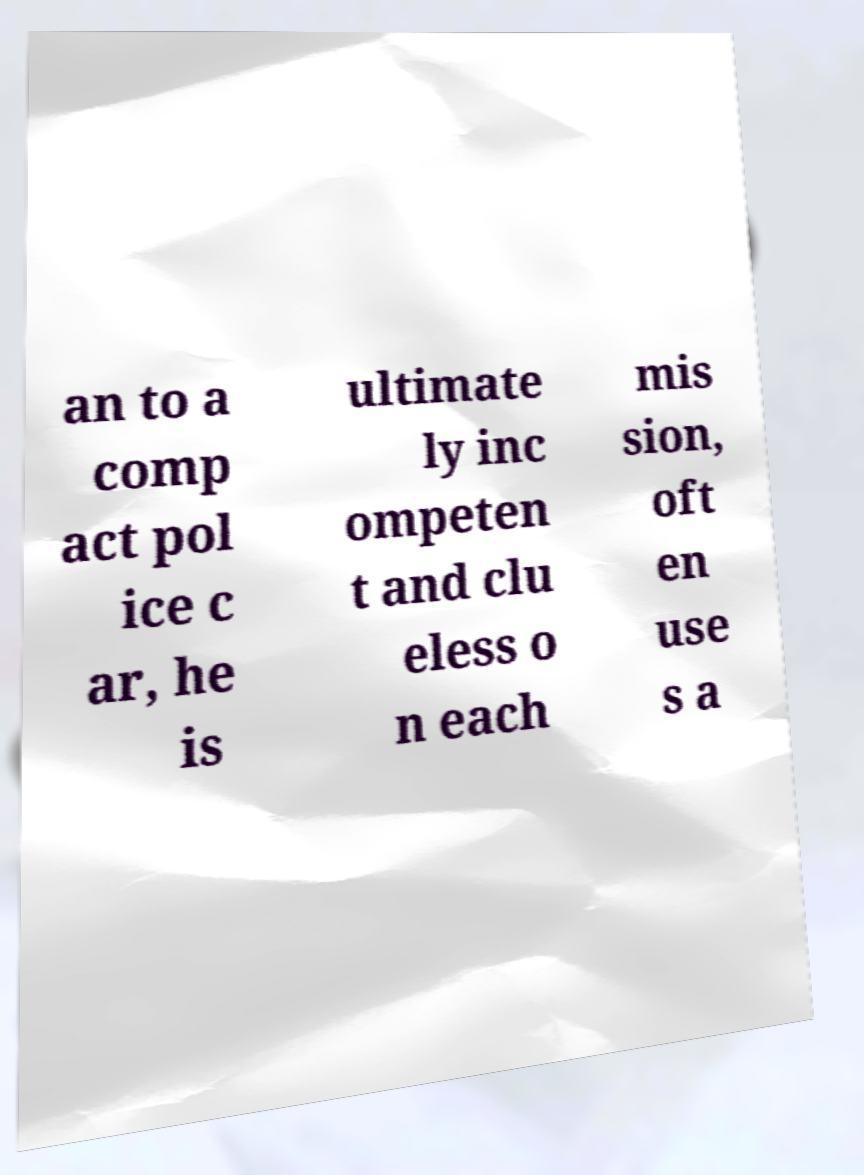There's text embedded in this image that I need extracted. Can you transcribe it verbatim? an to a comp act pol ice c ar, he is ultimate ly inc ompeten t and clu eless o n each mis sion, oft en use s a 